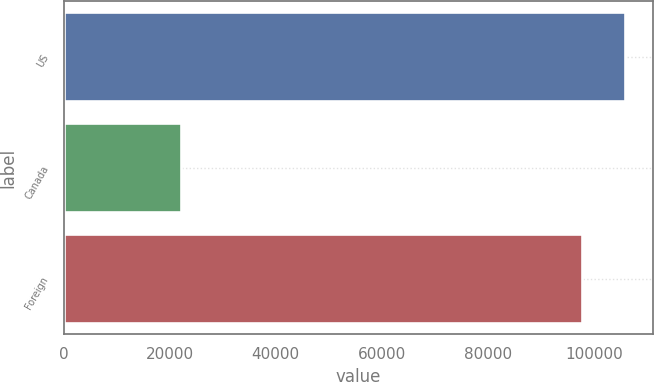<chart> <loc_0><loc_0><loc_500><loc_500><bar_chart><fcel>US<fcel>Canada<fcel>Foreign<nl><fcel>105975<fcel>22100<fcel>97881<nl></chart> 